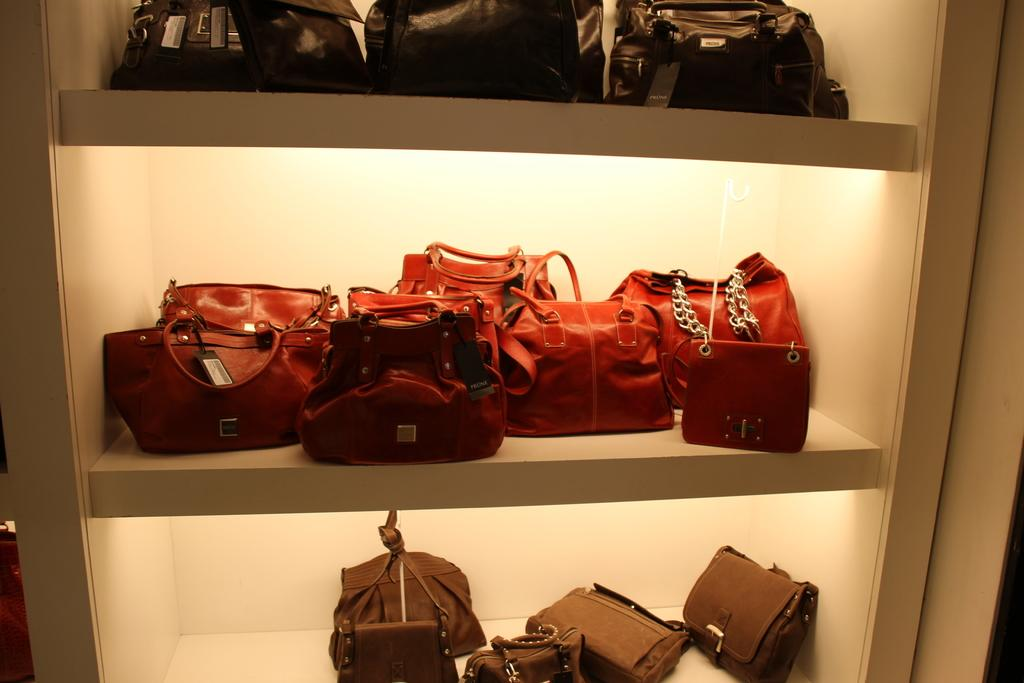What can be seen on the shelves in the image? There are handbags on the shelves in the image. How many shelves are visible in the image? The provided facts do not specify the number of shelves, so we cannot determine that from the information given. Are there any pigs present on the shelves in the image? There is no mention of pigs in the provided facts, so we cannot determine if there are any pigs present in the image. 